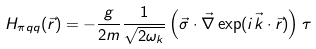<formula> <loc_0><loc_0><loc_500><loc_500>H _ { \pi q q } ( \vec { r } ) & = - \frac { g } { 2 m } \frac { 1 } { \sqrt { 2 \omega _ { k } } } \left ( \vec { \sigma } \cdot \vec { \nabla } \exp ( i \vec { k } \cdot \vec { r } ) \right ) \tau \,</formula> 